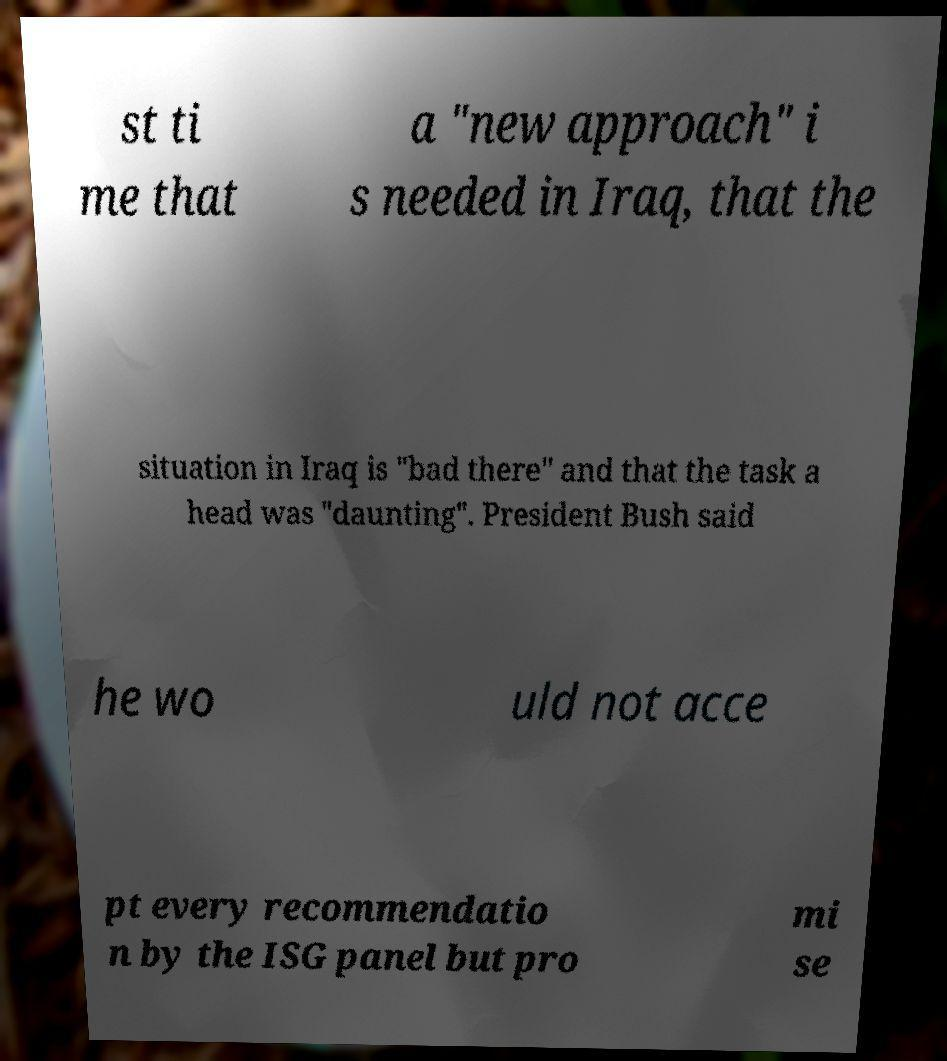Please identify and transcribe the text found in this image. st ti me that a "new approach" i s needed in Iraq, that the situation in Iraq is "bad there" and that the task a head was "daunting". President Bush said he wo uld not acce pt every recommendatio n by the ISG panel but pro mi se 